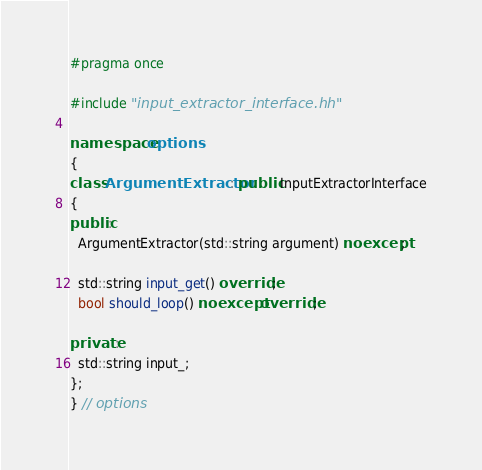Convert code to text. <code><loc_0><loc_0><loc_500><loc_500><_C++_>#pragma once

#include "input_extractor_interface.hh"

namespace options
{
class ArgumentExtractor : public InputExtractorInterface
{
public:
  ArgumentExtractor(std::string argument) noexcept;

  std::string input_get() override;
  bool should_loop() noexcept override;

private:
  std::string input_;
};
} // options
</code> 